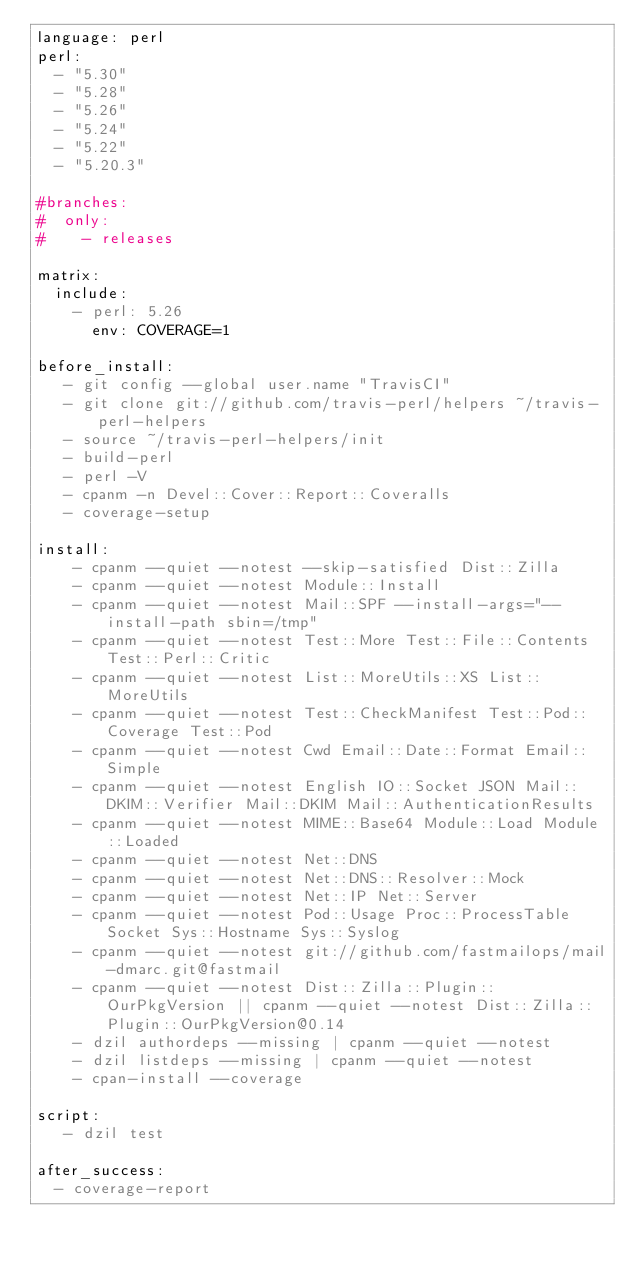<code> <loc_0><loc_0><loc_500><loc_500><_YAML_>language: perl
perl:
  - "5.30"
  - "5.28"
  - "5.26"
  - "5.24"
  - "5.22"
  - "5.20.3"

#branches:
#  only:
#    - releases

matrix:
  include:
    - perl: 5.26
      env: COVERAGE=1

before_install:
   - git config --global user.name "TravisCI"
   - git clone git://github.com/travis-perl/helpers ~/travis-perl-helpers
   - source ~/travis-perl-helpers/init
   - build-perl
   - perl -V
   - cpanm -n Devel::Cover::Report::Coveralls
   - coverage-setup

install:
    - cpanm --quiet --notest --skip-satisfied Dist::Zilla
    - cpanm --quiet --notest Module::Install
    - cpanm --quiet --notest Mail::SPF --install-args="--install-path sbin=/tmp"
    - cpanm --quiet --notest Test::More Test::File::Contents Test::Perl::Critic
    - cpanm --quiet --notest List::MoreUtils::XS List::MoreUtils
    - cpanm --quiet --notest Test::CheckManifest Test::Pod::Coverage Test::Pod
    - cpanm --quiet --notest Cwd Email::Date::Format Email::Simple
    - cpanm --quiet --notest English IO::Socket JSON Mail::DKIM::Verifier Mail::DKIM Mail::AuthenticationResults
    - cpanm --quiet --notest MIME::Base64 Module::Load Module::Loaded
    - cpanm --quiet --notest Net::DNS
    - cpanm --quiet --notest Net::DNS::Resolver::Mock
    - cpanm --quiet --notest Net::IP Net::Server
    - cpanm --quiet --notest Pod::Usage Proc::ProcessTable Socket Sys::Hostname Sys::Syslog
    - cpanm --quiet --notest git://github.com/fastmailops/mail-dmarc.git@fastmail
    - cpanm --quiet --notest Dist::Zilla::Plugin::OurPkgVersion || cpanm --quiet --notest Dist::Zilla::Plugin::OurPkgVersion@0.14
    - dzil authordeps --missing | cpanm --quiet --notest
    - dzil listdeps --missing | cpanm --quiet --notest
    - cpan-install --coverage

script:
   - dzil test

after_success:
  - coverage-report

</code> 